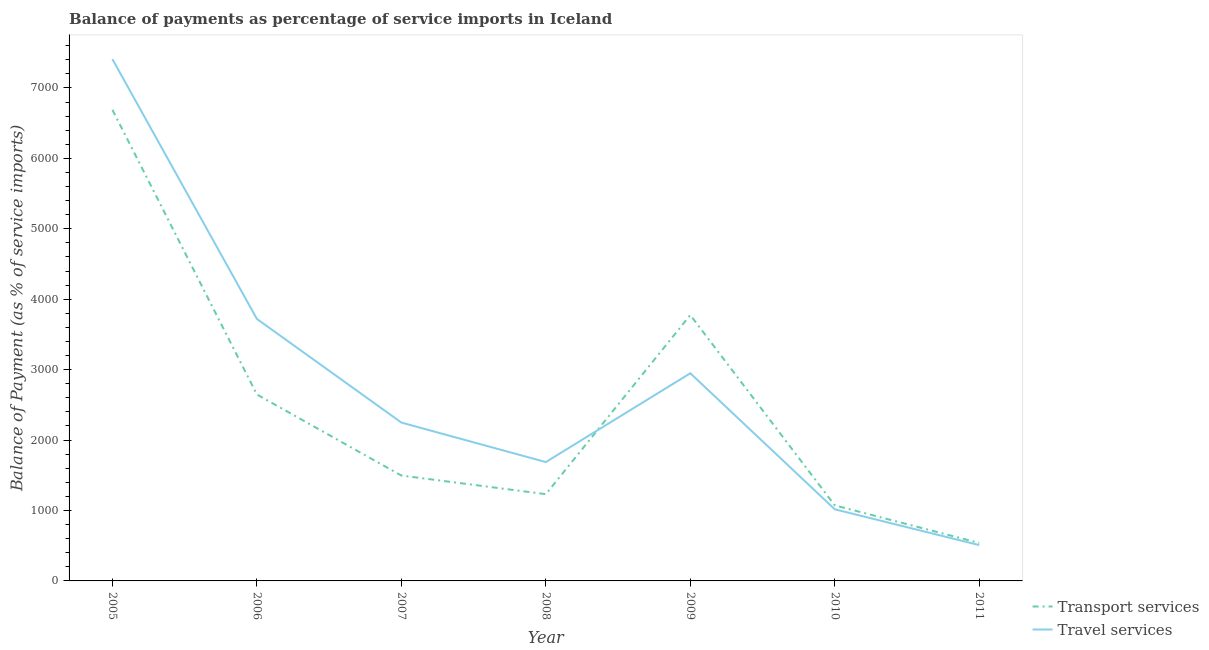How many different coloured lines are there?
Your response must be concise. 2. Does the line corresponding to balance of payments of travel services intersect with the line corresponding to balance of payments of transport services?
Provide a succinct answer. Yes. What is the balance of payments of travel services in 2005?
Ensure brevity in your answer.  7408.18. Across all years, what is the maximum balance of payments of travel services?
Ensure brevity in your answer.  7408.18. Across all years, what is the minimum balance of payments of travel services?
Provide a succinct answer. 508.61. What is the total balance of payments of transport services in the graph?
Offer a very short reply. 1.75e+04. What is the difference between the balance of payments of travel services in 2007 and that in 2008?
Make the answer very short. 560.86. What is the difference between the balance of payments of travel services in 2007 and the balance of payments of transport services in 2008?
Your answer should be compact. 1016.63. What is the average balance of payments of transport services per year?
Provide a short and direct response. 2493.01. In the year 2008, what is the difference between the balance of payments of transport services and balance of payments of travel services?
Your answer should be very brief. -455.76. What is the ratio of the balance of payments of transport services in 2008 to that in 2011?
Offer a very short reply. 2.29. What is the difference between the highest and the second highest balance of payments of travel services?
Provide a short and direct response. 3688.14. What is the difference between the highest and the lowest balance of payments of travel services?
Offer a very short reply. 6899.57. In how many years, is the balance of payments of transport services greater than the average balance of payments of transport services taken over all years?
Provide a succinct answer. 3. Does the balance of payments of travel services monotonically increase over the years?
Ensure brevity in your answer.  No. Is the balance of payments of travel services strictly less than the balance of payments of transport services over the years?
Provide a short and direct response. No. How many lines are there?
Give a very brief answer. 2. Are the values on the major ticks of Y-axis written in scientific E-notation?
Offer a very short reply. No. Does the graph contain any zero values?
Give a very brief answer. No. Where does the legend appear in the graph?
Offer a very short reply. Bottom right. How are the legend labels stacked?
Give a very brief answer. Vertical. What is the title of the graph?
Ensure brevity in your answer.  Balance of payments as percentage of service imports in Iceland. What is the label or title of the X-axis?
Ensure brevity in your answer.  Year. What is the label or title of the Y-axis?
Keep it short and to the point. Balance of Payment (as % of service imports). What is the Balance of Payment (as % of service imports) in Transport services in 2005?
Make the answer very short. 6689.16. What is the Balance of Payment (as % of service imports) in Travel services in 2005?
Make the answer very short. 7408.18. What is the Balance of Payment (as % of service imports) in Transport services in 2006?
Give a very brief answer. 2647.13. What is the Balance of Payment (as % of service imports) of Travel services in 2006?
Provide a succinct answer. 3720.04. What is the Balance of Payment (as % of service imports) of Transport services in 2007?
Keep it short and to the point. 1496.22. What is the Balance of Payment (as % of service imports) in Travel services in 2007?
Make the answer very short. 2248.42. What is the Balance of Payment (as % of service imports) of Transport services in 2008?
Ensure brevity in your answer.  1231.8. What is the Balance of Payment (as % of service imports) of Travel services in 2008?
Give a very brief answer. 1687.56. What is the Balance of Payment (as % of service imports) of Transport services in 2009?
Offer a very short reply. 3774.93. What is the Balance of Payment (as % of service imports) of Travel services in 2009?
Your response must be concise. 2948.8. What is the Balance of Payment (as % of service imports) of Transport services in 2010?
Offer a very short reply. 1072.78. What is the Balance of Payment (as % of service imports) in Travel services in 2010?
Offer a very short reply. 1017.05. What is the Balance of Payment (as % of service imports) of Transport services in 2011?
Provide a short and direct response. 539.07. What is the Balance of Payment (as % of service imports) of Travel services in 2011?
Your response must be concise. 508.61. Across all years, what is the maximum Balance of Payment (as % of service imports) of Transport services?
Provide a succinct answer. 6689.16. Across all years, what is the maximum Balance of Payment (as % of service imports) in Travel services?
Provide a succinct answer. 7408.18. Across all years, what is the minimum Balance of Payment (as % of service imports) in Transport services?
Offer a very short reply. 539.07. Across all years, what is the minimum Balance of Payment (as % of service imports) of Travel services?
Make the answer very short. 508.61. What is the total Balance of Payment (as % of service imports) in Transport services in the graph?
Your answer should be very brief. 1.75e+04. What is the total Balance of Payment (as % of service imports) in Travel services in the graph?
Ensure brevity in your answer.  1.95e+04. What is the difference between the Balance of Payment (as % of service imports) of Transport services in 2005 and that in 2006?
Your answer should be compact. 4042.03. What is the difference between the Balance of Payment (as % of service imports) of Travel services in 2005 and that in 2006?
Offer a terse response. 3688.14. What is the difference between the Balance of Payment (as % of service imports) of Transport services in 2005 and that in 2007?
Your answer should be compact. 5192.93. What is the difference between the Balance of Payment (as % of service imports) of Travel services in 2005 and that in 2007?
Ensure brevity in your answer.  5159.76. What is the difference between the Balance of Payment (as % of service imports) of Transport services in 2005 and that in 2008?
Provide a short and direct response. 5457.36. What is the difference between the Balance of Payment (as % of service imports) of Travel services in 2005 and that in 2008?
Your answer should be very brief. 5720.62. What is the difference between the Balance of Payment (as % of service imports) of Transport services in 2005 and that in 2009?
Your response must be concise. 2914.23. What is the difference between the Balance of Payment (as % of service imports) in Travel services in 2005 and that in 2009?
Your answer should be very brief. 4459.39. What is the difference between the Balance of Payment (as % of service imports) of Transport services in 2005 and that in 2010?
Provide a succinct answer. 5616.37. What is the difference between the Balance of Payment (as % of service imports) of Travel services in 2005 and that in 2010?
Keep it short and to the point. 6391.14. What is the difference between the Balance of Payment (as % of service imports) in Transport services in 2005 and that in 2011?
Give a very brief answer. 6150.08. What is the difference between the Balance of Payment (as % of service imports) of Travel services in 2005 and that in 2011?
Provide a short and direct response. 6899.57. What is the difference between the Balance of Payment (as % of service imports) of Transport services in 2006 and that in 2007?
Ensure brevity in your answer.  1150.91. What is the difference between the Balance of Payment (as % of service imports) in Travel services in 2006 and that in 2007?
Ensure brevity in your answer.  1471.62. What is the difference between the Balance of Payment (as % of service imports) of Transport services in 2006 and that in 2008?
Give a very brief answer. 1415.33. What is the difference between the Balance of Payment (as % of service imports) in Travel services in 2006 and that in 2008?
Provide a short and direct response. 2032.48. What is the difference between the Balance of Payment (as % of service imports) in Transport services in 2006 and that in 2009?
Your answer should be very brief. -1127.8. What is the difference between the Balance of Payment (as % of service imports) in Travel services in 2006 and that in 2009?
Your response must be concise. 771.25. What is the difference between the Balance of Payment (as % of service imports) in Transport services in 2006 and that in 2010?
Provide a short and direct response. 1574.34. What is the difference between the Balance of Payment (as % of service imports) in Travel services in 2006 and that in 2010?
Provide a short and direct response. 2703. What is the difference between the Balance of Payment (as % of service imports) of Transport services in 2006 and that in 2011?
Offer a terse response. 2108.06. What is the difference between the Balance of Payment (as % of service imports) of Travel services in 2006 and that in 2011?
Your response must be concise. 3211.43. What is the difference between the Balance of Payment (as % of service imports) in Transport services in 2007 and that in 2008?
Provide a succinct answer. 264.42. What is the difference between the Balance of Payment (as % of service imports) of Travel services in 2007 and that in 2008?
Your answer should be compact. 560.86. What is the difference between the Balance of Payment (as % of service imports) of Transport services in 2007 and that in 2009?
Provide a succinct answer. -2278.71. What is the difference between the Balance of Payment (as % of service imports) of Travel services in 2007 and that in 2009?
Offer a terse response. -700.37. What is the difference between the Balance of Payment (as % of service imports) in Transport services in 2007 and that in 2010?
Your answer should be compact. 423.44. What is the difference between the Balance of Payment (as % of service imports) of Travel services in 2007 and that in 2010?
Make the answer very short. 1231.38. What is the difference between the Balance of Payment (as % of service imports) of Transport services in 2007 and that in 2011?
Your answer should be very brief. 957.15. What is the difference between the Balance of Payment (as % of service imports) of Travel services in 2007 and that in 2011?
Make the answer very short. 1739.81. What is the difference between the Balance of Payment (as % of service imports) of Transport services in 2008 and that in 2009?
Offer a terse response. -2543.13. What is the difference between the Balance of Payment (as % of service imports) in Travel services in 2008 and that in 2009?
Provide a succinct answer. -1261.23. What is the difference between the Balance of Payment (as % of service imports) in Transport services in 2008 and that in 2010?
Keep it short and to the point. 159.01. What is the difference between the Balance of Payment (as % of service imports) of Travel services in 2008 and that in 2010?
Ensure brevity in your answer.  670.52. What is the difference between the Balance of Payment (as % of service imports) of Transport services in 2008 and that in 2011?
Provide a short and direct response. 692.73. What is the difference between the Balance of Payment (as % of service imports) of Travel services in 2008 and that in 2011?
Your answer should be very brief. 1178.95. What is the difference between the Balance of Payment (as % of service imports) of Transport services in 2009 and that in 2010?
Offer a very short reply. 2702.14. What is the difference between the Balance of Payment (as % of service imports) of Travel services in 2009 and that in 2010?
Give a very brief answer. 1931.75. What is the difference between the Balance of Payment (as % of service imports) in Transport services in 2009 and that in 2011?
Give a very brief answer. 3235.86. What is the difference between the Balance of Payment (as % of service imports) of Travel services in 2009 and that in 2011?
Provide a short and direct response. 2440.18. What is the difference between the Balance of Payment (as % of service imports) in Transport services in 2010 and that in 2011?
Offer a very short reply. 533.71. What is the difference between the Balance of Payment (as % of service imports) in Travel services in 2010 and that in 2011?
Your answer should be very brief. 508.44. What is the difference between the Balance of Payment (as % of service imports) in Transport services in 2005 and the Balance of Payment (as % of service imports) in Travel services in 2006?
Make the answer very short. 2969.11. What is the difference between the Balance of Payment (as % of service imports) in Transport services in 2005 and the Balance of Payment (as % of service imports) in Travel services in 2007?
Ensure brevity in your answer.  4440.73. What is the difference between the Balance of Payment (as % of service imports) in Transport services in 2005 and the Balance of Payment (as % of service imports) in Travel services in 2008?
Make the answer very short. 5001.59. What is the difference between the Balance of Payment (as % of service imports) of Transport services in 2005 and the Balance of Payment (as % of service imports) of Travel services in 2009?
Ensure brevity in your answer.  3740.36. What is the difference between the Balance of Payment (as % of service imports) in Transport services in 2005 and the Balance of Payment (as % of service imports) in Travel services in 2010?
Provide a succinct answer. 5672.11. What is the difference between the Balance of Payment (as % of service imports) in Transport services in 2005 and the Balance of Payment (as % of service imports) in Travel services in 2011?
Your response must be concise. 6180.54. What is the difference between the Balance of Payment (as % of service imports) of Transport services in 2006 and the Balance of Payment (as % of service imports) of Travel services in 2007?
Offer a very short reply. 398.7. What is the difference between the Balance of Payment (as % of service imports) in Transport services in 2006 and the Balance of Payment (as % of service imports) in Travel services in 2008?
Provide a succinct answer. 959.57. What is the difference between the Balance of Payment (as % of service imports) of Transport services in 2006 and the Balance of Payment (as % of service imports) of Travel services in 2009?
Make the answer very short. -301.67. What is the difference between the Balance of Payment (as % of service imports) of Transport services in 2006 and the Balance of Payment (as % of service imports) of Travel services in 2010?
Offer a very short reply. 1630.08. What is the difference between the Balance of Payment (as % of service imports) in Transport services in 2006 and the Balance of Payment (as % of service imports) in Travel services in 2011?
Give a very brief answer. 2138.52. What is the difference between the Balance of Payment (as % of service imports) of Transport services in 2007 and the Balance of Payment (as % of service imports) of Travel services in 2008?
Keep it short and to the point. -191.34. What is the difference between the Balance of Payment (as % of service imports) in Transport services in 2007 and the Balance of Payment (as % of service imports) in Travel services in 2009?
Ensure brevity in your answer.  -1452.57. What is the difference between the Balance of Payment (as % of service imports) of Transport services in 2007 and the Balance of Payment (as % of service imports) of Travel services in 2010?
Provide a short and direct response. 479.18. What is the difference between the Balance of Payment (as % of service imports) of Transport services in 2007 and the Balance of Payment (as % of service imports) of Travel services in 2011?
Keep it short and to the point. 987.61. What is the difference between the Balance of Payment (as % of service imports) of Transport services in 2008 and the Balance of Payment (as % of service imports) of Travel services in 2009?
Offer a terse response. -1717. What is the difference between the Balance of Payment (as % of service imports) in Transport services in 2008 and the Balance of Payment (as % of service imports) in Travel services in 2010?
Ensure brevity in your answer.  214.75. What is the difference between the Balance of Payment (as % of service imports) in Transport services in 2008 and the Balance of Payment (as % of service imports) in Travel services in 2011?
Keep it short and to the point. 723.19. What is the difference between the Balance of Payment (as % of service imports) of Transport services in 2009 and the Balance of Payment (as % of service imports) of Travel services in 2010?
Provide a succinct answer. 2757.88. What is the difference between the Balance of Payment (as % of service imports) of Transport services in 2009 and the Balance of Payment (as % of service imports) of Travel services in 2011?
Offer a terse response. 3266.32. What is the difference between the Balance of Payment (as % of service imports) in Transport services in 2010 and the Balance of Payment (as % of service imports) in Travel services in 2011?
Make the answer very short. 564.17. What is the average Balance of Payment (as % of service imports) of Transport services per year?
Ensure brevity in your answer.  2493.01. What is the average Balance of Payment (as % of service imports) in Travel services per year?
Provide a short and direct response. 2791.24. In the year 2005, what is the difference between the Balance of Payment (as % of service imports) of Transport services and Balance of Payment (as % of service imports) of Travel services?
Your response must be concise. -719.03. In the year 2006, what is the difference between the Balance of Payment (as % of service imports) in Transport services and Balance of Payment (as % of service imports) in Travel services?
Your answer should be compact. -1072.91. In the year 2007, what is the difference between the Balance of Payment (as % of service imports) in Transport services and Balance of Payment (as % of service imports) in Travel services?
Your response must be concise. -752.2. In the year 2008, what is the difference between the Balance of Payment (as % of service imports) of Transport services and Balance of Payment (as % of service imports) of Travel services?
Keep it short and to the point. -455.76. In the year 2009, what is the difference between the Balance of Payment (as % of service imports) of Transport services and Balance of Payment (as % of service imports) of Travel services?
Keep it short and to the point. 826.13. In the year 2010, what is the difference between the Balance of Payment (as % of service imports) of Transport services and Balance of Payment (as % of service imports) of Travel services?
Make the answer very short. 55.74. In the year 2011, what is the difference between the Balance of Payment (as % of service imports) of Transport services and Balance of Payment (as % of service imports) of Travel services?
Provide a short and direct response. 30.46. What is the ratio of the Balance of Payment (as % of service imports) in Transport services in 2005 to that in 2006?
Give a very brief answer. 2.53. What is the ratio of the Balance of Payment (as % of service imports) of Travel services in 2005 to that in 2006?
Offer a very short reply. 1.99. What is the ratio of the Balance of Payment (as % of service imports) in Transport services in 2005 to that in 2007?
Keep it short and to the point. 4.47. What is the ratio of the Balance of Payment (as % of service imports) of Travel services in 2005 to that in 2007?
Offer a very short reply. 3.29. What is the ratio of the Balance of Payment (as % of service imports) of Transport services in 2005 to that in 2008?
Your response must be concise. 5.43. What is the ratio of the Balance of Payment (as % of service imports) of Travel services in 2005 to that in 2008?
Offer a terse response. 4.39. What is the ratio of the Balance of Payment (as % of service imports) in Transport services in 2005 to that in 2009?
Make the answer very short. 1.77. What is the ratio of the Balance of Payment (as % of service imports) of Travel services in 2005 to that in 2009?
Your answer should be very brief. 2.51. What is the ratio of the Balance of Payment (as % of service imports) of Transport services in 2005 to that in 2010?
Keep it short and to the point. 6.24. What is the ratio of the Balance of Payment (as % of service imports) in Travel services in 2005 to that in 2010?
Make the answer very short. 7.28. What is the ratio of the Balance of Payment (as % of service imports) in Transport services in 2005 to that in 2011?
Offer a very short reply. 12.41. What is the ratio of the Balance of Payment (as % of service imports) of Travel services in 2005 to that in 2011?
Keep it short and to the point. 14.57. What is the ratio of the Balance of Payment (as % of service imports) in Transport services in 2006 to that in 2007?
Give a very brief answer. 1.77. What is the ratio of the Balance of Payment (as % of service imports) in Travel services in 2006 to that in 2007?
Offer a very short reply. 1.65. What is the ratio of the Balance of Payment (as % of service imports) of Transport services in 2006 to that in 2008?
Keep it short and to the point. 2.15. What is the ratio of the Balance of Payment (as % of service imports) in Travel services in 2006 to that in 2008?
Give a very brief answer. 2.2. What is the ratio of the Balance of Payment (as % of service imports) of Transport services in 2006 to that in 2009?
Your answer should be very brief. 0.7. What is the ratio of the Balance of Payment (as % of service imports) of Travel services in 2006 to that in 2009?
Provide a short and direct response. 1.26. What is the ratio of the Balance of Payment (as % of service imports) in Transport services in 2006 to that in 2010?
Provide a short and direct response. 2.47. What is the ratio of the Balance of Payment (as % of service imports) in Travel services in 2006 to that in 2010?
Provide a short and direct response. 3.66. What is the ratio of the Balance of Payment (as % of service imports) in Transport services in 2006 to that in 2011?
Your answer should be very brief. 4.91. What is the ratio of the Balance of Payment (as % of service imports) of Travel services in 2006 to that in 2011?
Offer a very short reply. 7.31. What is the ratio of the Balance of Payment (as % of service imports) of Transport services in 2007 to that in 2008?
Make the answer very short. 1.21. What is the ratio of the Balance of Payment (as % of service imports) in Travel services in 2007 to that in 2008?
Provide a short and direct response. 1.33. What is the ratio of the Balance of Payment (as % of service imports) of Transport services in 2007 to that in 2009?
Provide a succinct answer. 0.4. What is the ratio of the Balance of Payment (as % of service imports) in Travel services in 2007 to that in 2009?
Your answer should be compact. 0.76. What is the ratio of the Balance of Payment (as % of service imports) in Transport services in 2007 to that in 2010?
Offer a very short reply. 1.39. What is the ratio of the Balance of Payment (as % of service imports) in Travel services in 2007 to that in 2010?
Offer a very short reply. 2.21. What is the ratio of the Balance of Payment (as % of service imports) of Transport services in 2007 to that in 2011?
Ensure brevity in your answer.  2.78. What is the ratio of the Balance of Payment (as % of service imports) in Travel services in 2007 to that in 2011?
Your answer should be compact. 4.42. What is the ratio of the Balance of Payment (as % of service imports) of Transport services in 2008 to that in 2009?
Keep it short and to the point. 0.33. What is the ratio of the Balance of Payment (as % of service imports) in Travel services in 2008 to that in 2009?
Your response must be concise. 0.57. What is the ratio of the Balance of Payment (as % of service imports) of Transport services in 2008 to that in 2010?
Make the answer very short. 1.15. What is the ratio of the Balance of Payment (as % of service imports) of Travel services in 2008 to that in 2010?
Offer a terse response. 1.66. What is the ratio of the Balance of Payment (as % of service imports) of Transport services in 2008 to that in 2011?
Your response must be concise. 2.29. What is the ratio of the Balance of Payment (as % of service imports) in Travel services in 2008 to that in 2011?
Provide a short and direct response. 3.32. What is the ratio of the Balance of Payment (as % of service imports) of Transport services in 2009 to that in 2010?
Ensure brevity in your answer.  3.52. What is the ratio of the Balance of Payment (as % of service imports) of Travel services in 2009 to that in 2010?
Your response must be concise. 2.9. What is the ratio of the Balance of Payment (as % of service imports) of Transport services in 2009 to that in 2011?
Make the answer very short. 7. What is the ratio of the Balance of Payment (as % of service imports) of Travel services in 2009 to that in 2011?
Your answer should be very brief. 5.8. What is the ratio of the Balance of Payment (as % of service imports) in Transport services in 2010 to that in 2011?
Ensure brevity in your answer.  1.99. What is the ratio of the Balance of Payment (as % of service imports) of Travel services in 2010 to that in 2011?
Give a very brief answer. 2. What is the difference between the highest and the second highest Balance of Payment (as % of service imports) in Transport services?
Offer a very short reply. 2914.23. What is the difference between the highest and the second highest Balance of Payment (as % of service imports) in Travel services?
Your answer should be very brief. 3688.14. What is the difference between the highest and the lowest Balance of Payment (as % of service imports) of Transport services?
Ensure brevity in your answer.  6150.08. What is the difference between the highest and the lowest Balance of Payment (as % of service imports) in Travel services?
Offer a terse response. 6899.57. 